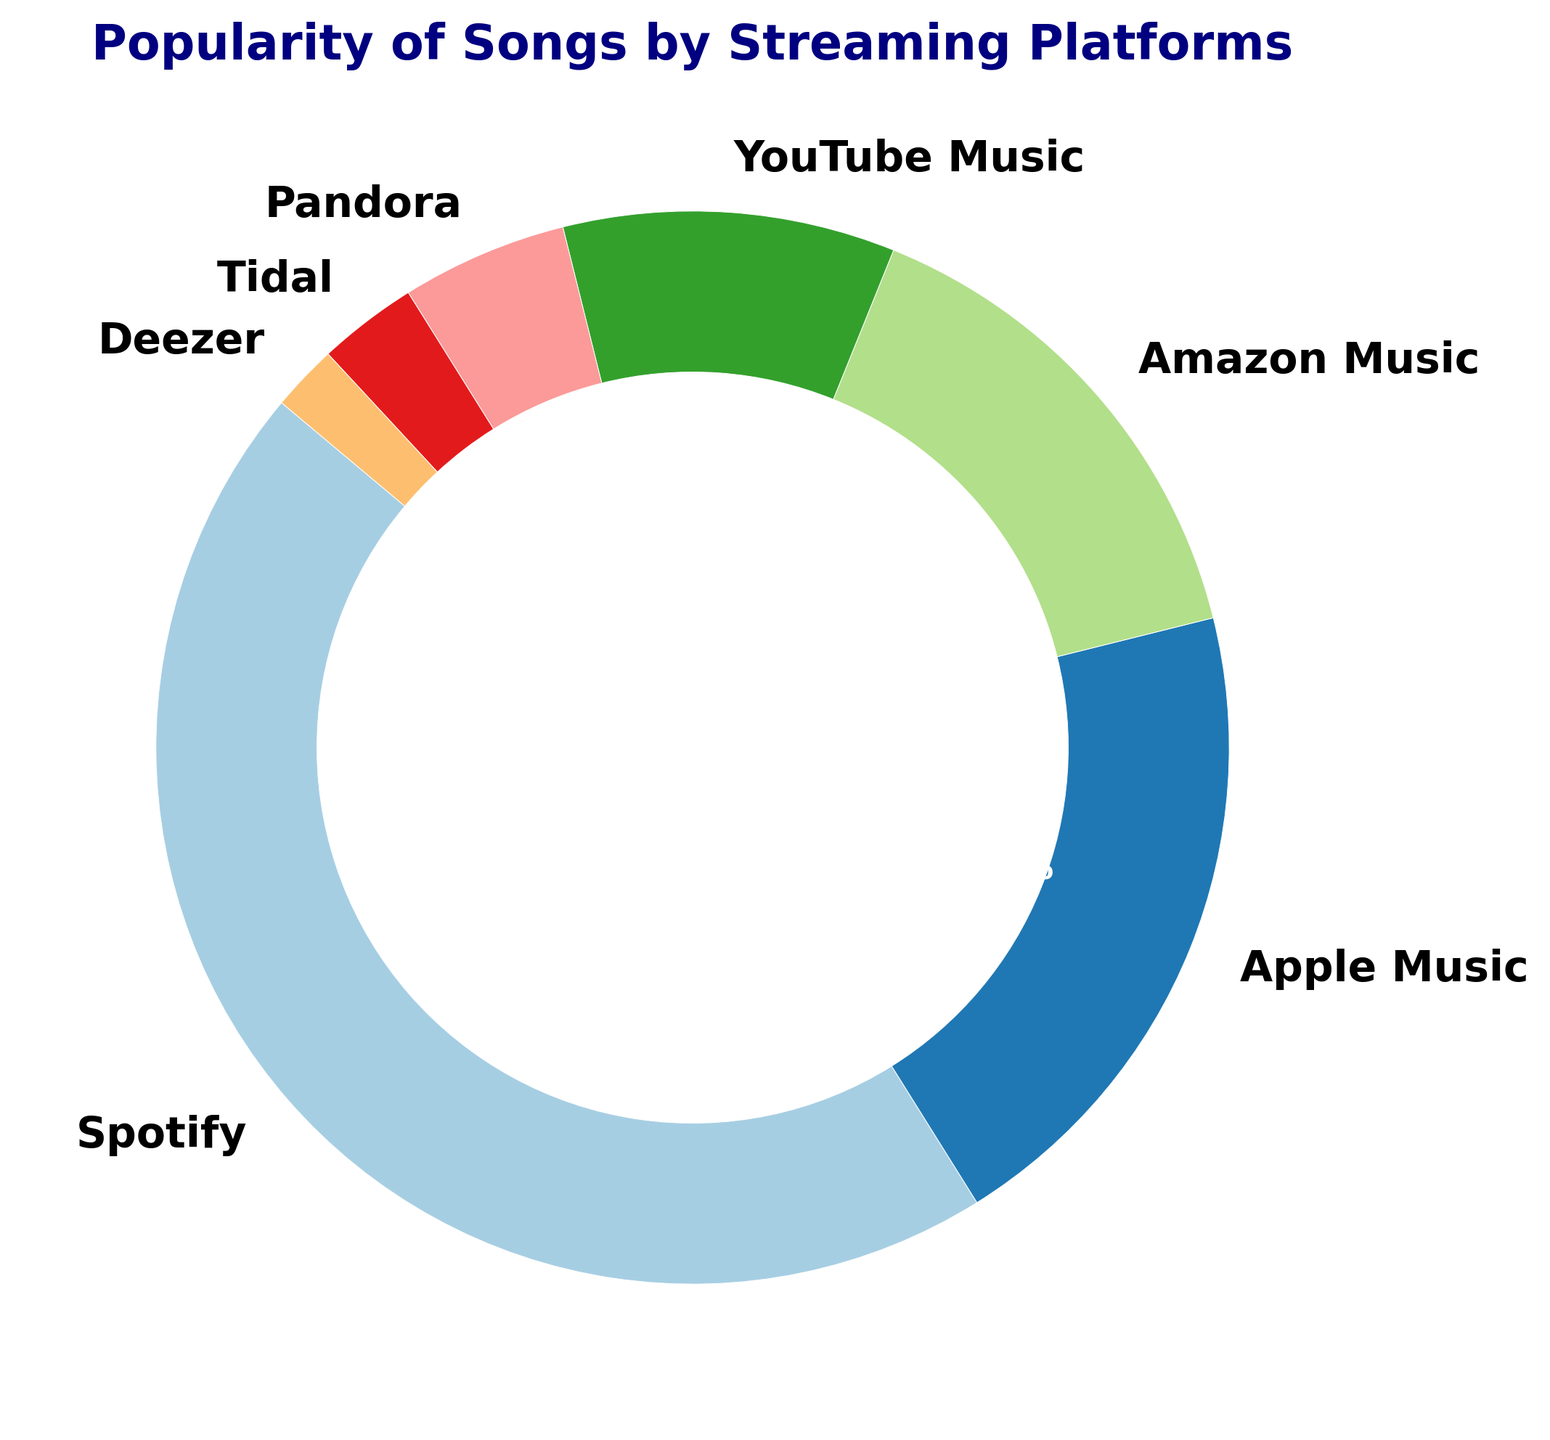What's the most popular platform for streaming songs? The figure shows a pie chart with percentages representing the popularity of each streaming platform. Spotify has the largest section with 45%.
Answer: Spotify Which platform has the smallest share of song popularity? The smallest section of the pie chart is represented by Deezer with 2%.
Answer: Deezer How much more popular is Spotify compared to Apple Music? Spotify has 45% and Apple Music has 20%. The difference is 45% - 20% = 25%.
Answer: 25% What is the combined percentage of the least popular three platforms? The least popular three platforms are Tidal (3%), Deezer (2%), and Pandora (5%). The combined percentage is 3% + 2% + 5% = 10%.
Answer: 10% Which platforms have more than 10% popularity? From the pie chart, Spotify (45%), Apple Music (20%), and Amazon Music (15%) all have more than 10% popularity.
Answer: Spotify, Apple Music, Amazon Music Is the total percentage of the top three platforms greater than or less than 80%? The top three platforms are Spotify (45%), Apple Music (20%), and Amazon Music (15%). Their combined percentage is 45% + 20% + 15% = 80%.
Answer: Equal to 80% What proportion of the pie chart is represented by YouTube Music and Pandora combined? YouTube Music represents 10% and Pandora represents 5%. Combined, they account for 10% + 5% = 15%.
Answer: 15% Which color represents YouTube Music in the pie chart? The pie chart uses the 'Paired' color palette, where YouTube Music is indicated by the section corresponding to 10%, typically a specific color in the palette (based on your visualization specific context, describe the color).
Answer: [Here you will describe the specific color seen in the pie chart for YouTube Music, for example, "red" if that matches the visualization] How does the popularity of Amazon Music compare to that of Pandora? Amazon Music has 15% and Pandora has 5%. Therefore, Amazon Music is three times more popular than Pandora.
Answer: Three times more What's the total percentage of platforms that are less popular than Amazon Music? Platforms less popular than Amazon Music are YouTube Music (10%), Pandora (5%), Tidal (3%), and Deezer (2%). Their combined percentage is 10% + 5% + 3% + 2% = 20%.
Answer: 20% 